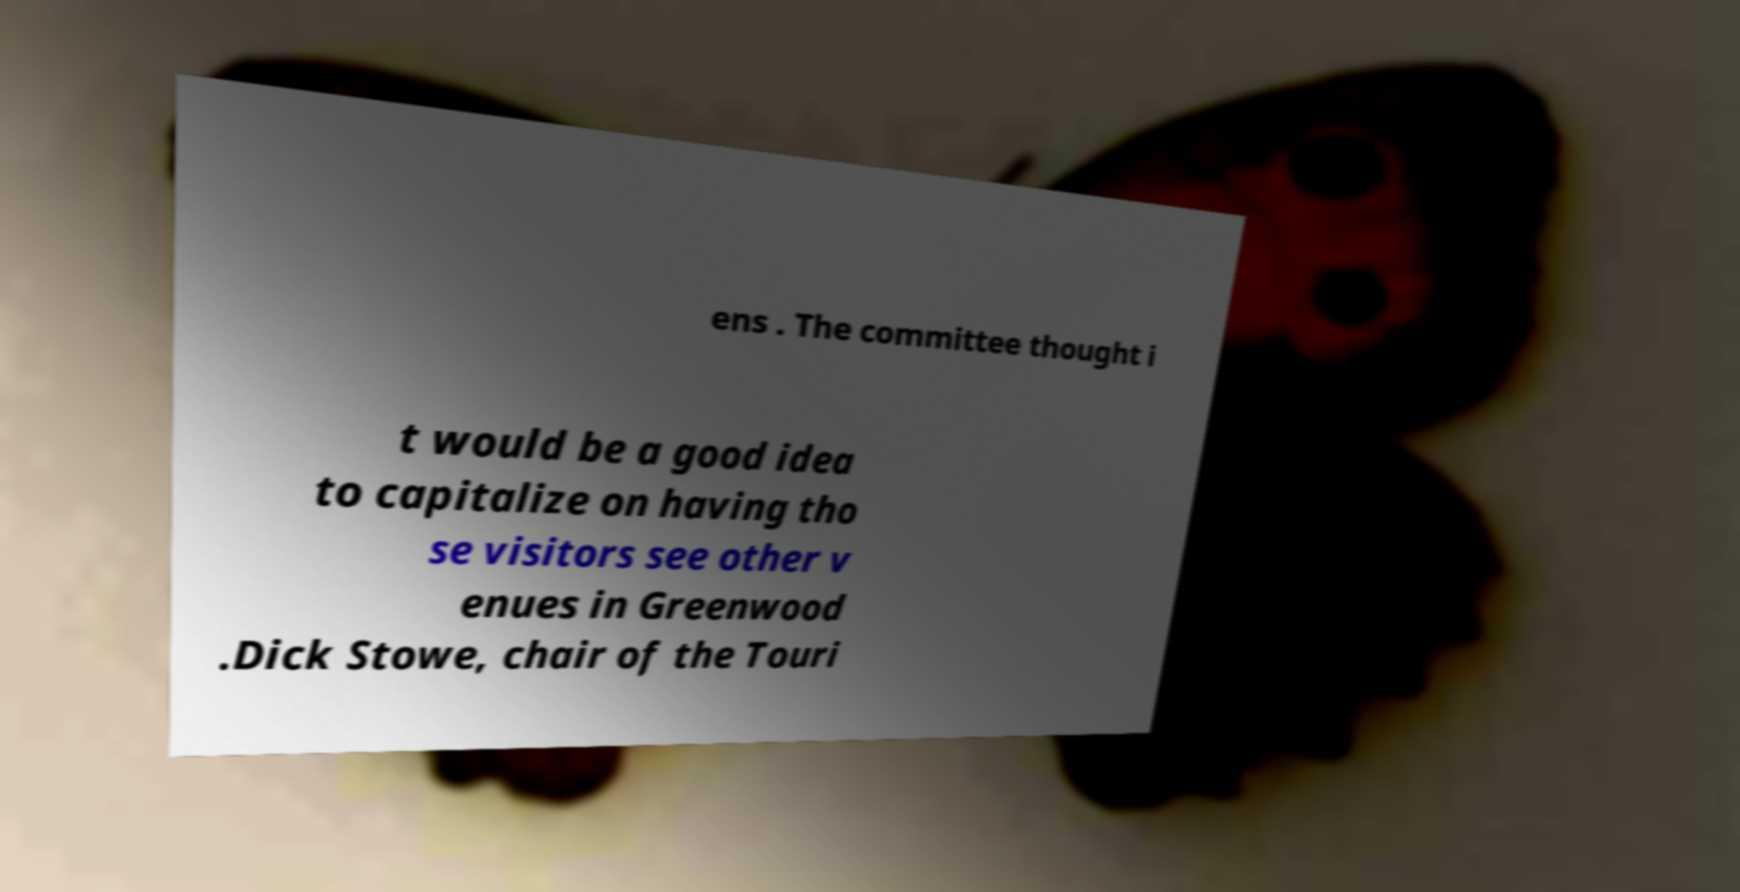For documentation purposes, I need the text within this image transcribed. Could you provide that? ens . The committee thought i t would be a good idea to capitalize on having tho se visitors see other v enues in Greenwood .Dick Stowe, chair of the Touri 